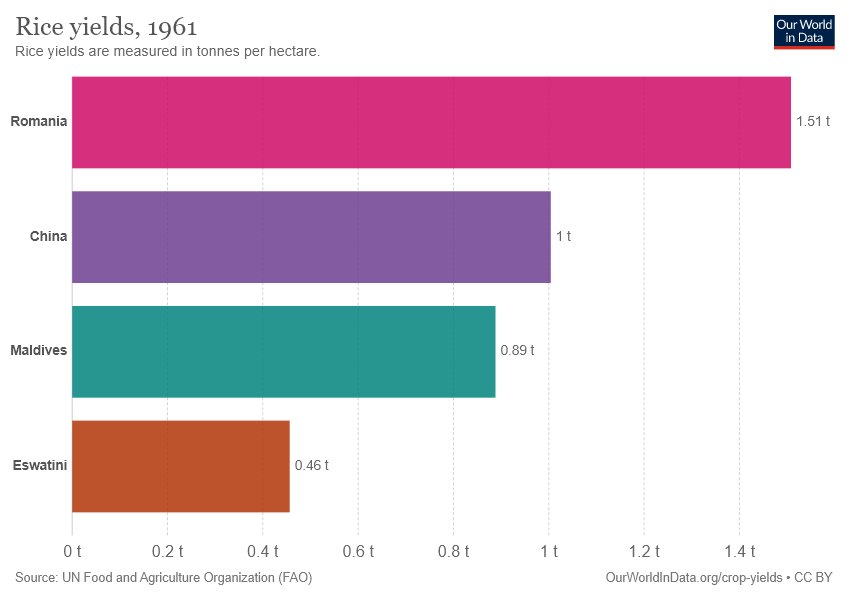Specify some key components in this picture. The value of rice yields in China is 1. The total number of rice yields among all countries is 3.86... 